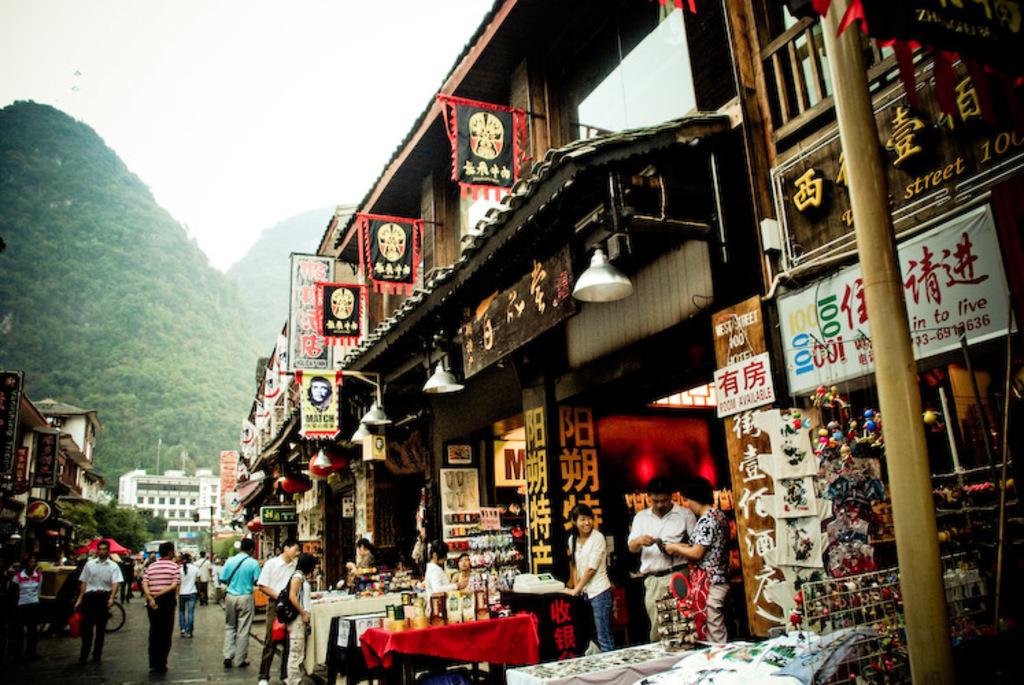What number is printed three times on the white banner on the right?
Offer a terse response. 100. 